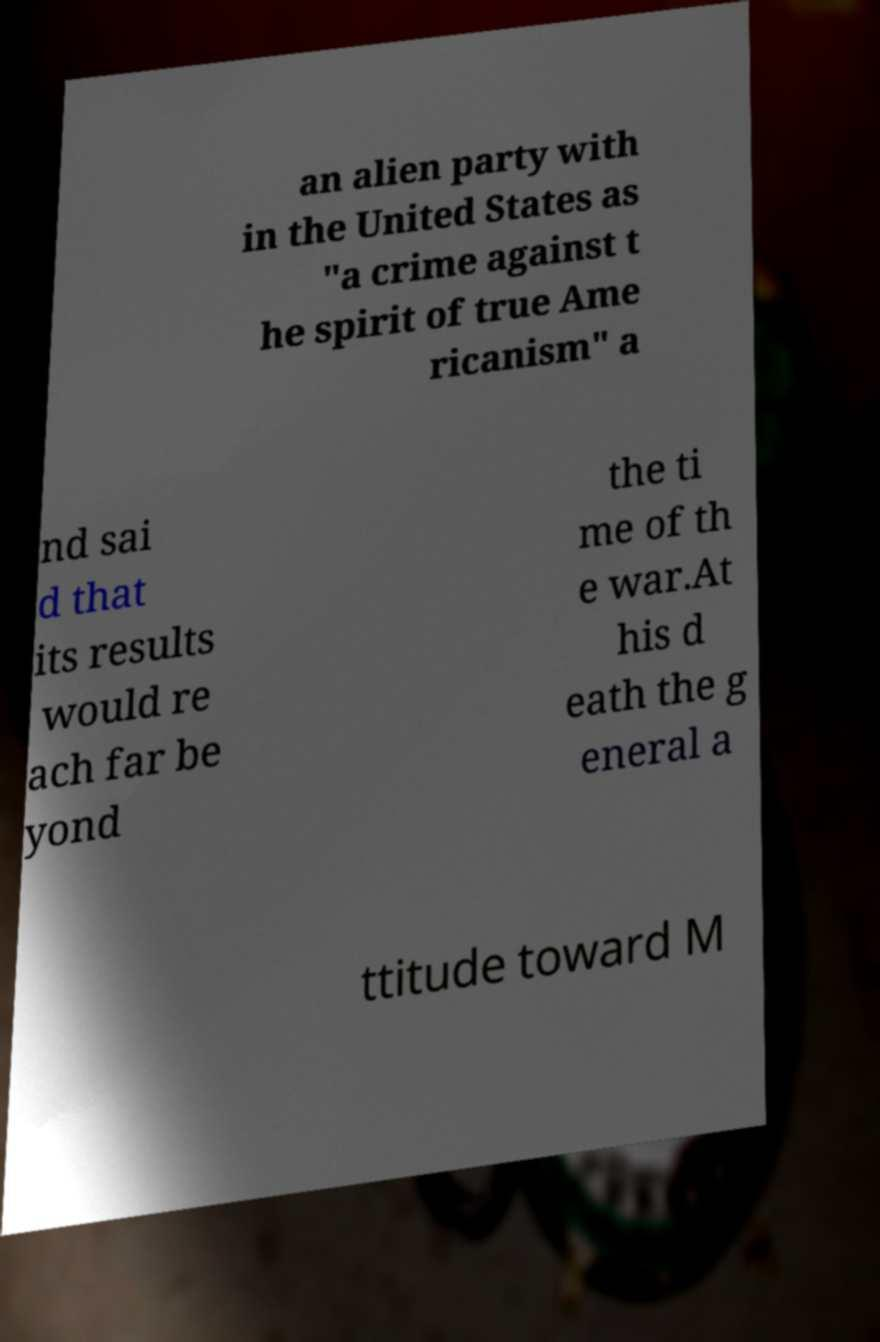Could you extract and type out the text from this image? an alien party with in the United States as "a crime against t he spirit of true Ame ricanism" a nd sai d that its results would re ach far be yond the ti me of th e war.At his d eath the g eneral a ttitude toward M 